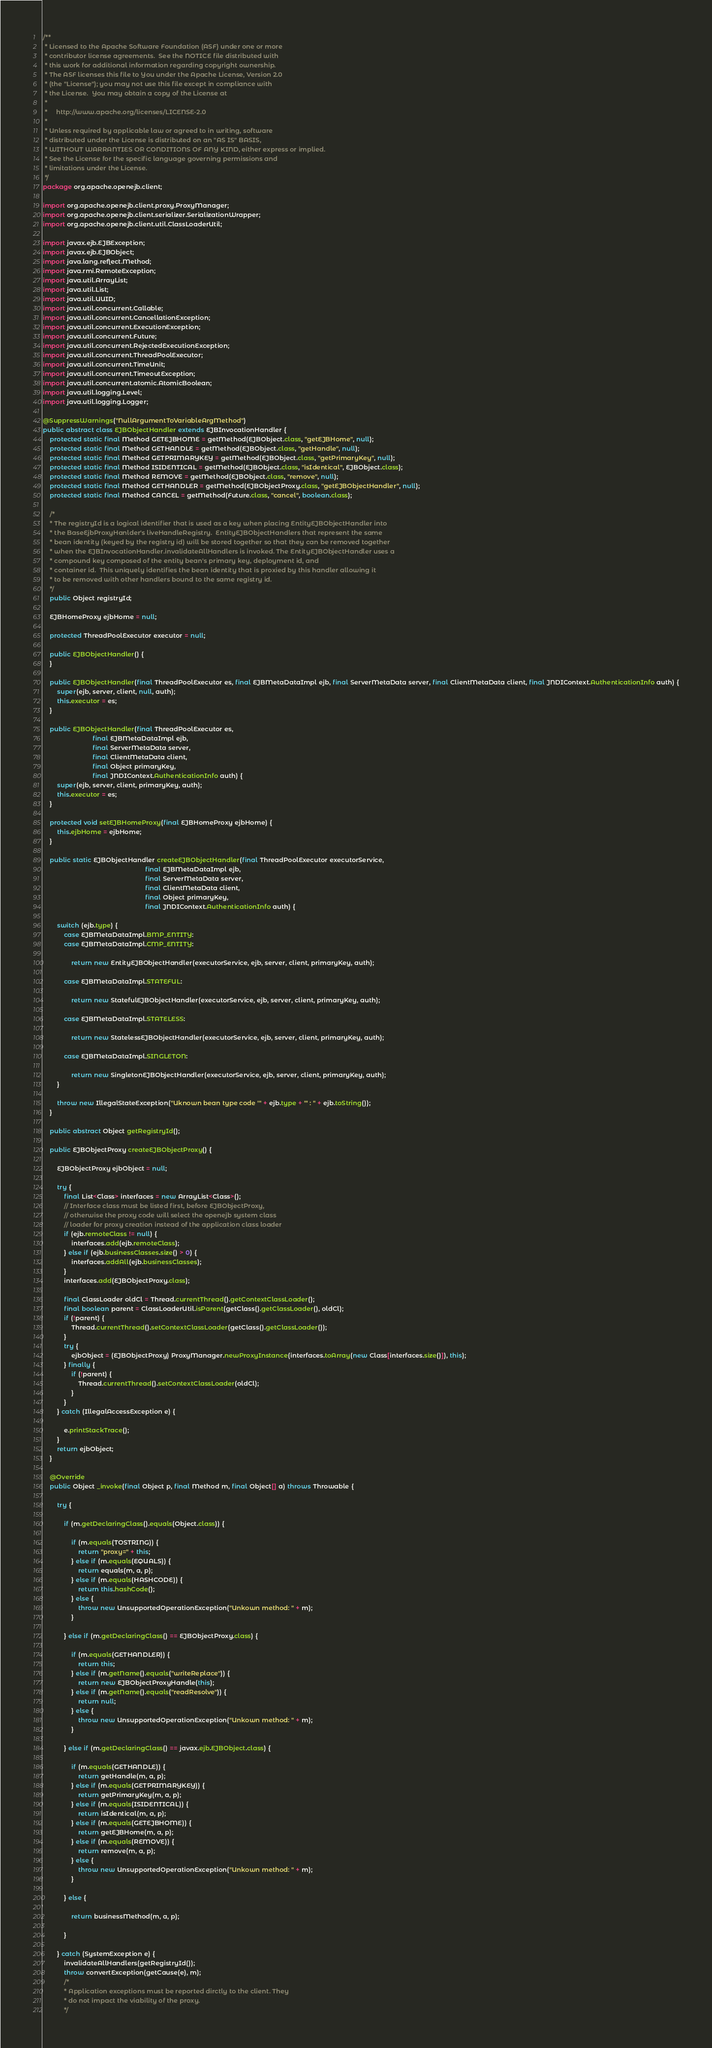<code> <loc_0><loc_0><loc_500><loc_500><_Java_>/**
 * Licensed to the Apache Software Foundation (ASF) under one or more
 * contributor license agreements.  See the NOTICE file distributed with
 * this work for additional information regarding copyright ownership.
 * The ASF licenses this file to You under the Apache License, Version 2.0
 * (the "License"); you may not use this file except in compliance with
 * the License.  You may obtain a copy of the License at
 *
 *     http://www.apache.org/licenses/LICENSE-2.0
 *
 * Unless required by applicable law or agreed to in writing, software
 * distributed under the License is distributed on an "AS IS" BASIS,
 * WITHOUT WARRANTIES OR CONDITIONS OF ANY KIND, either express or implied.
 * See the License for the specific language governing permissions and
 * limitations under the License.
 */
package org.apache.openejb.client;

import org.apache.openejb.client.proxy.ProxyManager;
import org.apache.openejb.client.serializer.SerializationWrapper;
import org.apache.openejb.client.util.ClassLoaderUtil;

import javax.ejb.EJBException;
import javax.ejb.EJBObject;
import java.lang.reflect.Method;
import java.rmi.RemoteException;
import java.util.ArrayList;
import java.util.List;
import java.util.UUID;
import java.util.concurrent.Callable;
import java.util.concurrent.CancellationException;
import java.util.concurrent.ExecutionException;
import java.util.concurrent.Future;
import java.util.concurrent.RejectedExecutionException;
import java.util.concurrent.ThreadPoolExecutor;
import java.util.concurrent.TimeUnit;
import java.util.concurrent.TimeoutException;
import java.util.concurrent.atomic.AtomicBoolean;
import java.util.logging.Level;
import java.util.logging.Logger;

@SuppressWarnings("NullArgumentToVariableArgMethod")
public abstract class EJBObjectHandler extends EJBInvocationHandler {
    protected static final Method GETEJBHOME = getMethod(EJBObject.class, "getEJBHome", null);
    protected static final Method GETHANDLE = getMethod(EJBObject.class, "getHandle", null);
    protected static final Method GETPRIMARYKEY = getMethod(EJBObject.class, "getPrimaryKey", null);
    protected static final Method ISIDENTICAL = getMethod(EJBObject.class, "isIdentical", EJBObject.class);
    protected static final Method REMOVE = getMethod(EJBObject.class, "remove", null);
    protected static final Method GETHANDLER = getMethod(EJBObjectProxy.class, "getEJBObjectHandler", null);
    protected static final Method CANCEL = getMethod(Future.class, "cancel", boolean.class);

    /*
    * The registryId is a logical identifier that is used as a key when placing EntityEJBObjectHandler into
    * the BaseEjbProxyHanlder's liveHandleRegistry.  EntityEJBObjectHandlers that represent the same
    * bean identity (keyed by the registry id) will be stored together so that they can be removed together
    * when the EJBInvocationHandler.invalidateAllHandlers is invoked. The EntityEJBObjectHandler uses a
    * compound key composed of the entity bean's primary key, deployment id, and
    * container id.  This uniquely identifies the bean identity that is proxied by this handler allowing it
    * to be removed with other handlers bound to the same registry id.
    */
    public Object registryId;

    EJBHomeProxy ejbHome = null;

    protected ThreadPoolExecutor executor = null;

    public EJBObjectHandler() {
    }

    public EJBObjectHandler(final ThreadPoolExecutor es, final EJBMetaDataImpl ejb, final ServerMetaData server, final ClientMetaData client, final JNDIContext.AuthenticationInfo auth) {
        super(ejb, server, client, null, auth);
        this.executor = es;
    }

    public EJBObjectHandler(final ThreadPoolExecutor es,
                            final EJBMetaDataImpl ejb,
                            final ServerMetaData server,
                            final ClientMetaData client,
                            final Object primaryKey,
                            final JNDIContext.AuthenticationInfo auth) {
        super(ejb, server, client, primaryKey, auth);
        this.executor = es;
    }

    protected void setEJBHomeProxy(final EJBHomeProxy ejbHome) {
        this.ejbHome = ejbHome;
    }

    public static EJBObjectHandler createEJBObjectHandler(final ThreadPoolExecutor executorService,
                                                          final EJBMetaDataImpl ejb,
                                                          final ServerMetaData server,
                                                          final ClientMetaData client,
                                                          final Object primaryKey,
                                                          final JNDIContext.AuthenticationInfo auth) {

        switch (ejb.type) {
            case EJBMetaDataImpl.BMP_ENTITY:
            case EJBMetaDataImpl.CMP_ENTITY:

                return new EntityEJBObjectHandler(executorService, ejb, server, client, primaryKey, auth);

            case EJBMetaDataImpl.STATEFUL:

                return new StatefulEJBObjectHandler(executorService, ejb, server, client, primaryKey, auth);

            case EJBMetaDataImpl.STATELESS:

                return new StatelessEJBObjectHandler(executorService, ejb, server, client, primaryKey, auth);

            case EJBMetaDataImpl.SINGLETON:

                return new SingletonEJBObjectHandler(executorService, ejb, server, client, primaryKey, auth);
        }

        throw new IllegalStateException("Uknown bean type code '" + ejb.type + "' : " + ejb.toString());
    }

    public abstract Object getRegistryId();

    public EJBObjectProxy createEJBObjectProxy() {

        EJBObjectProxy ejbObject = null;

        try {
            final List<Class> interfaces = new ArrayList<Class>();
            // Interface class must be listed first, before EJBObjectProxy,
            // otherwise the proxy code will select the openejb system class
            // loader for proxy creation instead of the application class loader
            if (ejb.remoteClass != null) {
                interfaces.add(ejb.remoteClass);
            } else if (ejb.businessClasses.size() > 0) {
                interfaces.addAll(ejb.businessClasses);
            }
            interfaces.add(EJBObjectProxy.class);

            final ClassLoader oldCl = Thread.currentThread().getContextClassLoader();
            final boolean parent = ClassLoaderUtil.isParent(getClass().getClassLoader(), oldCl);
            if (!parent) {
                Thread.currentThread().setContextClassLoader(getClass().getClassLoader());
            }
            try {
                ejbObject = (EJBObjectProxy) ProxyManager.newProxyInstance(interfaces.toArray(new Class[interfaces.size()]), this);
            } finally {
                if (!parent) {
                    Thread.currentThread().setContextClassLoader(oldCl);
                }
            }
        } catch (IllegalAccessException e) {

            e.printStackTrace();
        }
        return ejbObject;
    }

    @Override
    public Object _invoke(final Object p, final Method m, final Object[] a) throws Throwable {

        try {

            if (m.getDeclaringClass().equals(Object.class)) {

                if (m.equals(TOSTRING)) {
                    return "proxy=" + this;
                } else if (m.equals(EQUALS)) {
                    return equals(m, a, p);
                } else if (m.equals(HASHCODE)) {
                    return this.hashCode();
                } else {
                    throw new UnsupportedOperationException("Unkown method: " + m);
                }

            } else if (m.getDeclaringClass() == EJBObjectProxy.class) {

                if (m.equals(GETHANDLER)) {
                    return this;
                } else if (m.getName().equals("writeReplace")) {
                    return new EJBObjectProxyHandle(this);
                } else if (m.getName().equals("readResolve")) {
                    return null;
                } else {
                    throw new UnsupportedOperationException("Unkown method: " + m);
                }

            } else if (m.getDeclaringClass() == javax.ejb.EJBObject.class) {

                if (m.equals(GETHANDLE)) {
                    return getHandle(m, a, p);
                } else if (m.equals(GETPRIMARYKEY)) {
                    return getPrimaryKey(m, a, p);
                } else if (m.equals(ISIDENTICAL)) {
                    return isIdentical(m, a, p);
                } else if (m.equals(GETEJBHOME)) {
                    return getEJBHome(m, a, p);
                } else if (m.equals(REMOVE)) {
                    return remove(m, a, p);
                } else {
                    throw new UnsupportedOperationException("Unkown method: " + m);
                }

            } else {

                return businessMethod(m, a, p);

            }

        } catch (SystemException e) {
            invalidateAllHandlers(getRegistryId());
            throw convertException(getCause(e), m);
            /*
            * Application exceptions must be reported dirctly to the client. They
            * do not impact the viability of the proxy.
            */</code> 